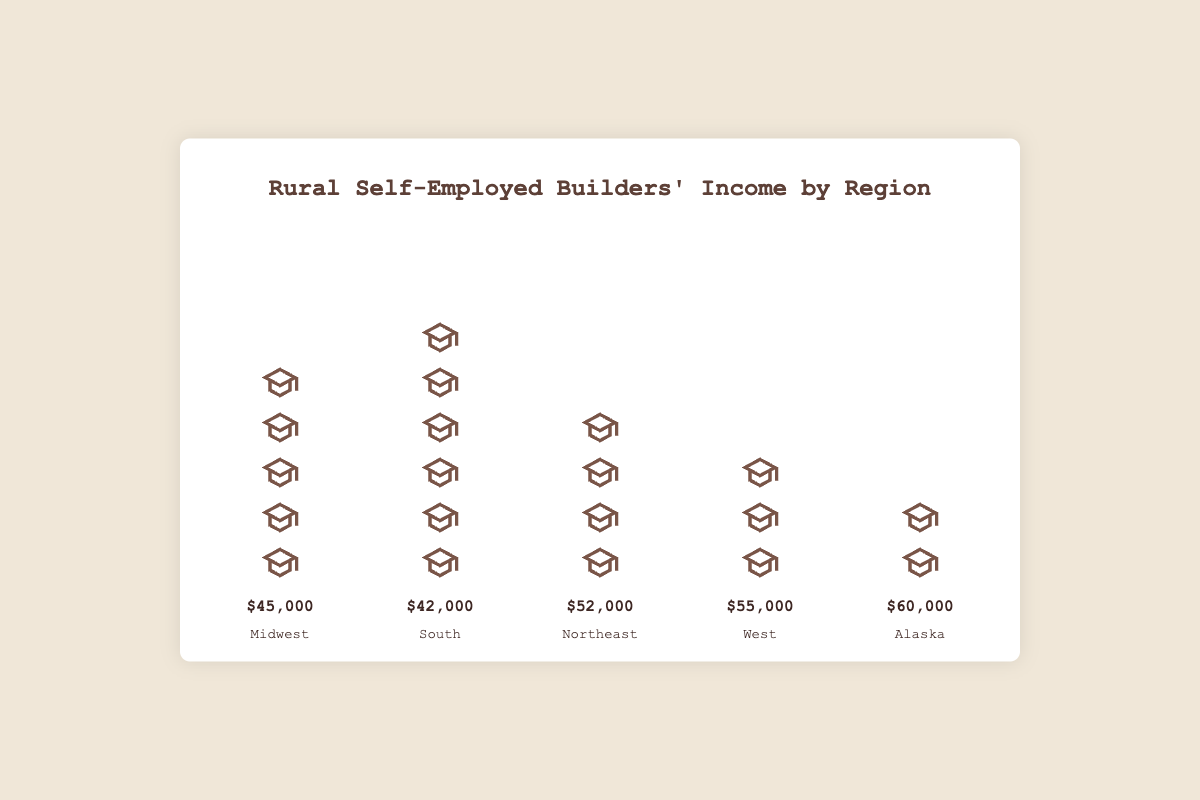What's the title of the figure? The title can be found at the top of the figure, typically larger and bold to attract attention. It states the overall subject of the plot.
Answer: Rural Self-Employed Builders' Income by Region Which region has the highest income? Identify the tallest column or the label showing the highest income. The "Alaska" region has the highest income indicated by its $60,000 label.
Answer: Alaska How many builders are represented in the "South"? Count the number of builder icons or blocks in the "South" region. The South region has 6 builder icons.
Answer: 6 What is the difference in income between the Northeast and the Midwest? Locate the income values for both regions. Northeast income is $52,000, and Midwest income is $45,000. Subtract Midwest income from Northeast income: $52,000 - $45,000 = $7,000.
Answer: $7,000 Which region has fewer builders, West or Northeast? Compare the number of builder icons in both regions. The West has 3 builders, while the Northeast has 4 builders. Since 3 < 4, the West has fewer builders.
Answer: West What is the total number of builders across all regions? Sum up the number of builders in each region: 5 (Midwest) + 6 (South) + 4 (Northeast) + 3 (West) + 2 (Alaska) = 20.
Answer: 20 Which region has the lowest income? Identify the region with the shortest column or the label showing the lowest income. The South region has the lowest income indicated by $42,000.
Answer: South What is the average income of builders in the West? Identify the income of the West, which is $55,000, then acknowledge all builders in this region share this income equally. Thus, the average income per builder is the total income divided by the number of builders, $55,000 / 3 = $18,333.33. (Note: This assumes "income" is total, not per builder.)
Answer: $18,333.33 How much more income does the Alaska region have compared to the South? Compare the income values directly. Alaska's income is $60,000, and the South's income is $42,000. Compute the difference: $60,000 - $42,000 = $18,000.
Answer: $18,000 